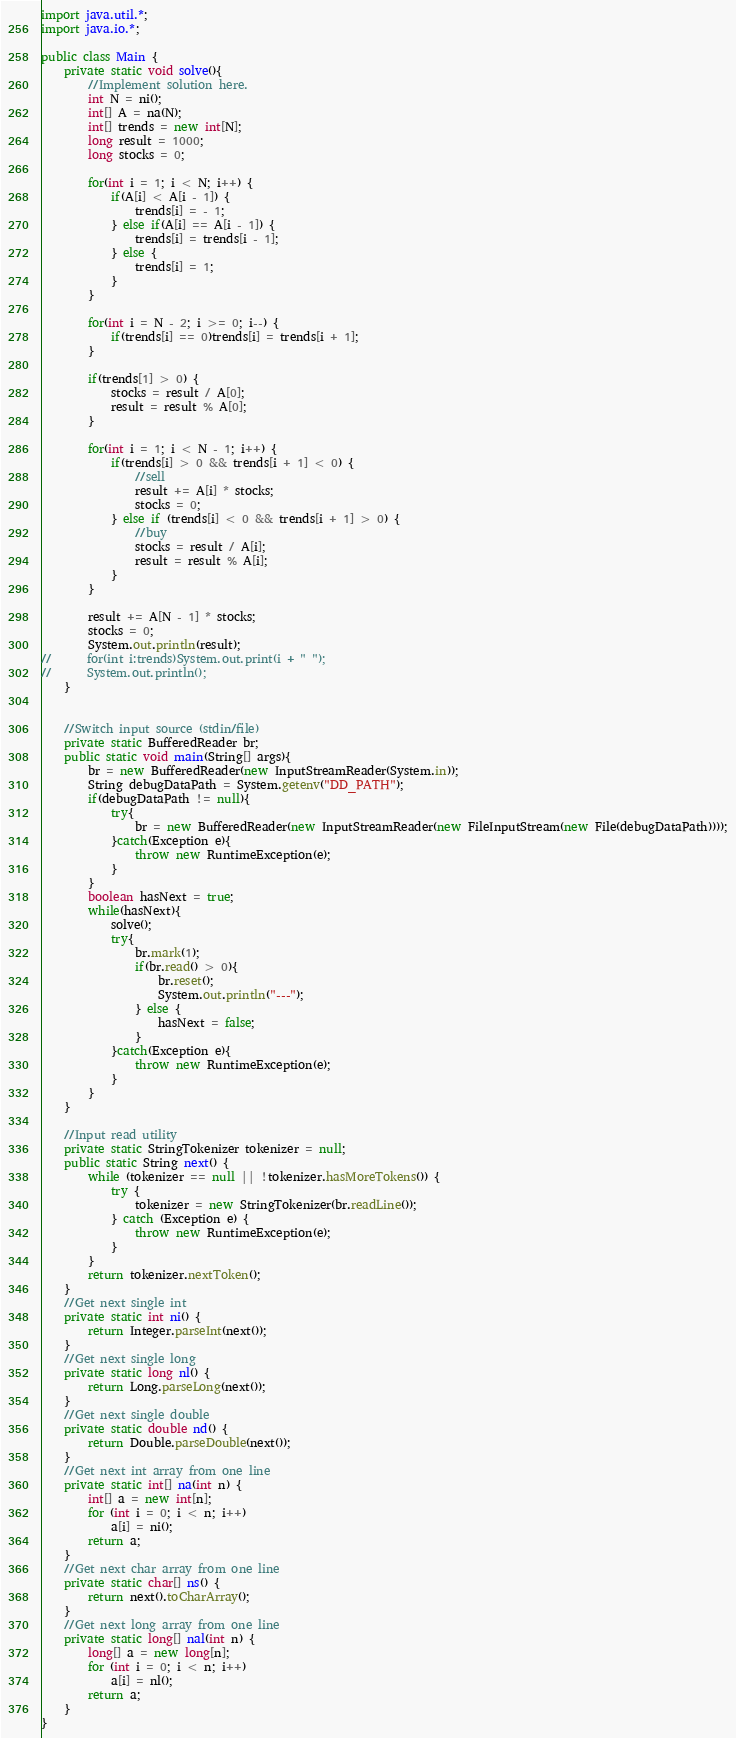Convert code to text. <code><loc_0><loc_0><loc_500><loc_500><_Java_>import java.util.*;
import java.io.*;

public class Main {
	private static void solve(){
		//Implement solution here.
		int N = ni();
		int[] A = na(N);
		int[] trends = new int[N];
		long result = 1000;
		long stocks = 0;
		
		for(int i = 1; i < N; i++) {
			if(A[i] < A[i - 1]) {
				trends[i] = - 1;
			} else if(A[i] == A[i - 1]) {
				trends[i] = trends[i - 1];
			} else {
				trends[i] = 1;
			}
		}
		
		for(int i = N - 2; i >= 0; i--) {
			if(trends[i] == 0)trends[i] = trends[i + 1];
		}
		
		if(trends[1] > 0) {			
			stocks = result / A[0];
			result = result % A[0];			
		}
		
		for(int i = 1; i < N - 1; i++) {
			if(trends[i] > 0 && trends[i + 1] < 0) {
				//sell
				result += A[i] * stocks;
				stocks = 0;
			} else if (trends[i] < 0 && trends[i + 1] > 0) {
				//buy
				stocks = result / A[i];
				result = result % A[i];				
			}
		}
		
		result += A[N - 1] * stocks;
		stocks = 0;
		System.out.println(result);
//		for(int i:trends)System.out.print(i + " ");
//		System.out.println();
	}


	//Switch input source (stdin/file)
	private static BufferedReader br;
	public static void main(String[] args){
		br = new BufferedReader(new InputStreamReader(System.in));
		String debugDataPath = System.getenv("DD_PATH");        
		if(debugDataPath != null){
			try{
				br = new BufferedReader(new InputStreamReader(new FileInputStream(new File(debugDataPath))));
			}catch(Exception e){
				throw new RuntimeException(e);
			}
		}
		boolean hasNext = true;
		while(hasNext){
			solve();	
			try{
				br.mark(1);
				if(br.read() > 0){
					br.reset();			
					System.out.println("---");
				} else {
					hasNext = false;
				}
			}catch(Exception e){
				throw new RuntimeException(e);
			} 
		}
	}

	//Input read utility
	private static StringTokenizer tokenizer = null;
	public static String next() {
		while (tokenizer == null || !tokenizer.hasMoreTokens()) {
			try {
				tokenizer = new StringTokenizer(br.readLine());
			} catch (Exception e) {
				throw new RuntimeException(e);
			}
		}
		return tokenizer.nextToken();
	}
	//Get next single int
	private static int ni() {
		return Integer.parseInt(next());
	}
	//Get next single long
	private static long nl() {
		return Long.parseLong(next());
	}
	//Get next single double
	private static double nd() {
		return Double.parseDouble(next());
	}
	//Get next int array from one line
	private static int[] na(int n) {
		int[] a = new int[n];
		for (int i = 0; i < n; i++)
			a[i] = ni();
		return a;
	}
	//Get next char array from one line
	private static char[] ns() {
		return next().toCharArray();
	}
	//Get next long array from one line
	private static long[] nal(int n) {
		long[] a = new long[n];
		for (int i = 0; i < n; i++)
			a[i] = nl();
		return a;
	}
}
</code> 